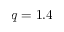<formula> <loc_0><loc_0><loc_500><loc_500>q = 1 . 4</formula> 